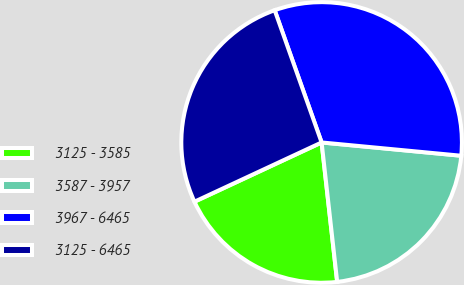Convert chart. <chart><loc_0><loc_0><loc_500><loc_500><pie_chart><fcel>3125 - 3585<fcel>3587 - 3957<fcel>3967 - 6465<fcel>3125 - 6465<nl><fcel>19.83%<fcel>21.72%<fcel>31.94%<fcel>26.51%<nl></chart> 